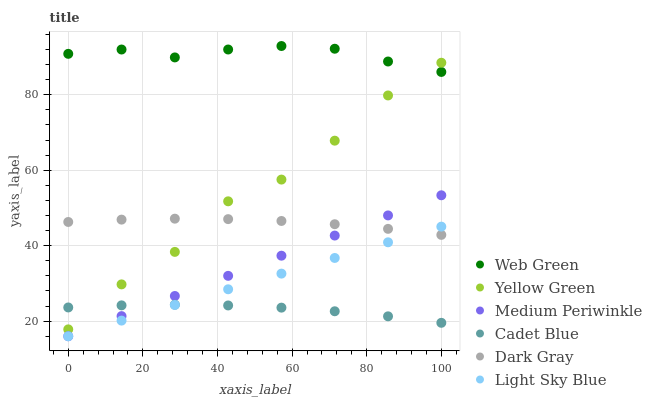Does Cadet Blue have the minimum area under the curve?
Answer yes or no. Yes. Does Web Green have the maximum area under the curve?
Answer yes or no. Yes. Does Yellow Green have the minimum area under the curve?
Answer yes or no. No. Does Yellow Green have the maximum area under the curve?
Answer yes or no. No. Is Light Sky Blue the smoothest?
Answer yes or no. Yes. Is Yellow Green the roughest?
Answer yes or no. Yes. Is Medium Periwinkle the smoothest?
Answer yes or no. No. Is Medium Periwinkle the roughest?
Answer yes or no. No. Does Medium Periwinkle have the lowest value?
Answer yes or no. Yes. Does Yellow Green have the lowest value?
Answer yes or no. No. Does Web Green have the highest value?
Answer yes or no. Yes. Does Yellow Green have the highest value?
Answer yes or no. No. Is Cadet Blue less than Dark Gray?
Answer yes or no. Yes. Is Web Green greater than Medium Periwinkle?
Answer yes or no. Yes. Does Dark Gray intersect Light Sky Blue?
Answer yes or no. Yes. Is Dark Gray less than Light Sky Blue?
Answer yes or no. No. Is Dark Gray greater than Light Sky Blue?
Answer yes or no. No. Does Cadet Blue intersect Dark Gray?
Answer yes or no. No. 